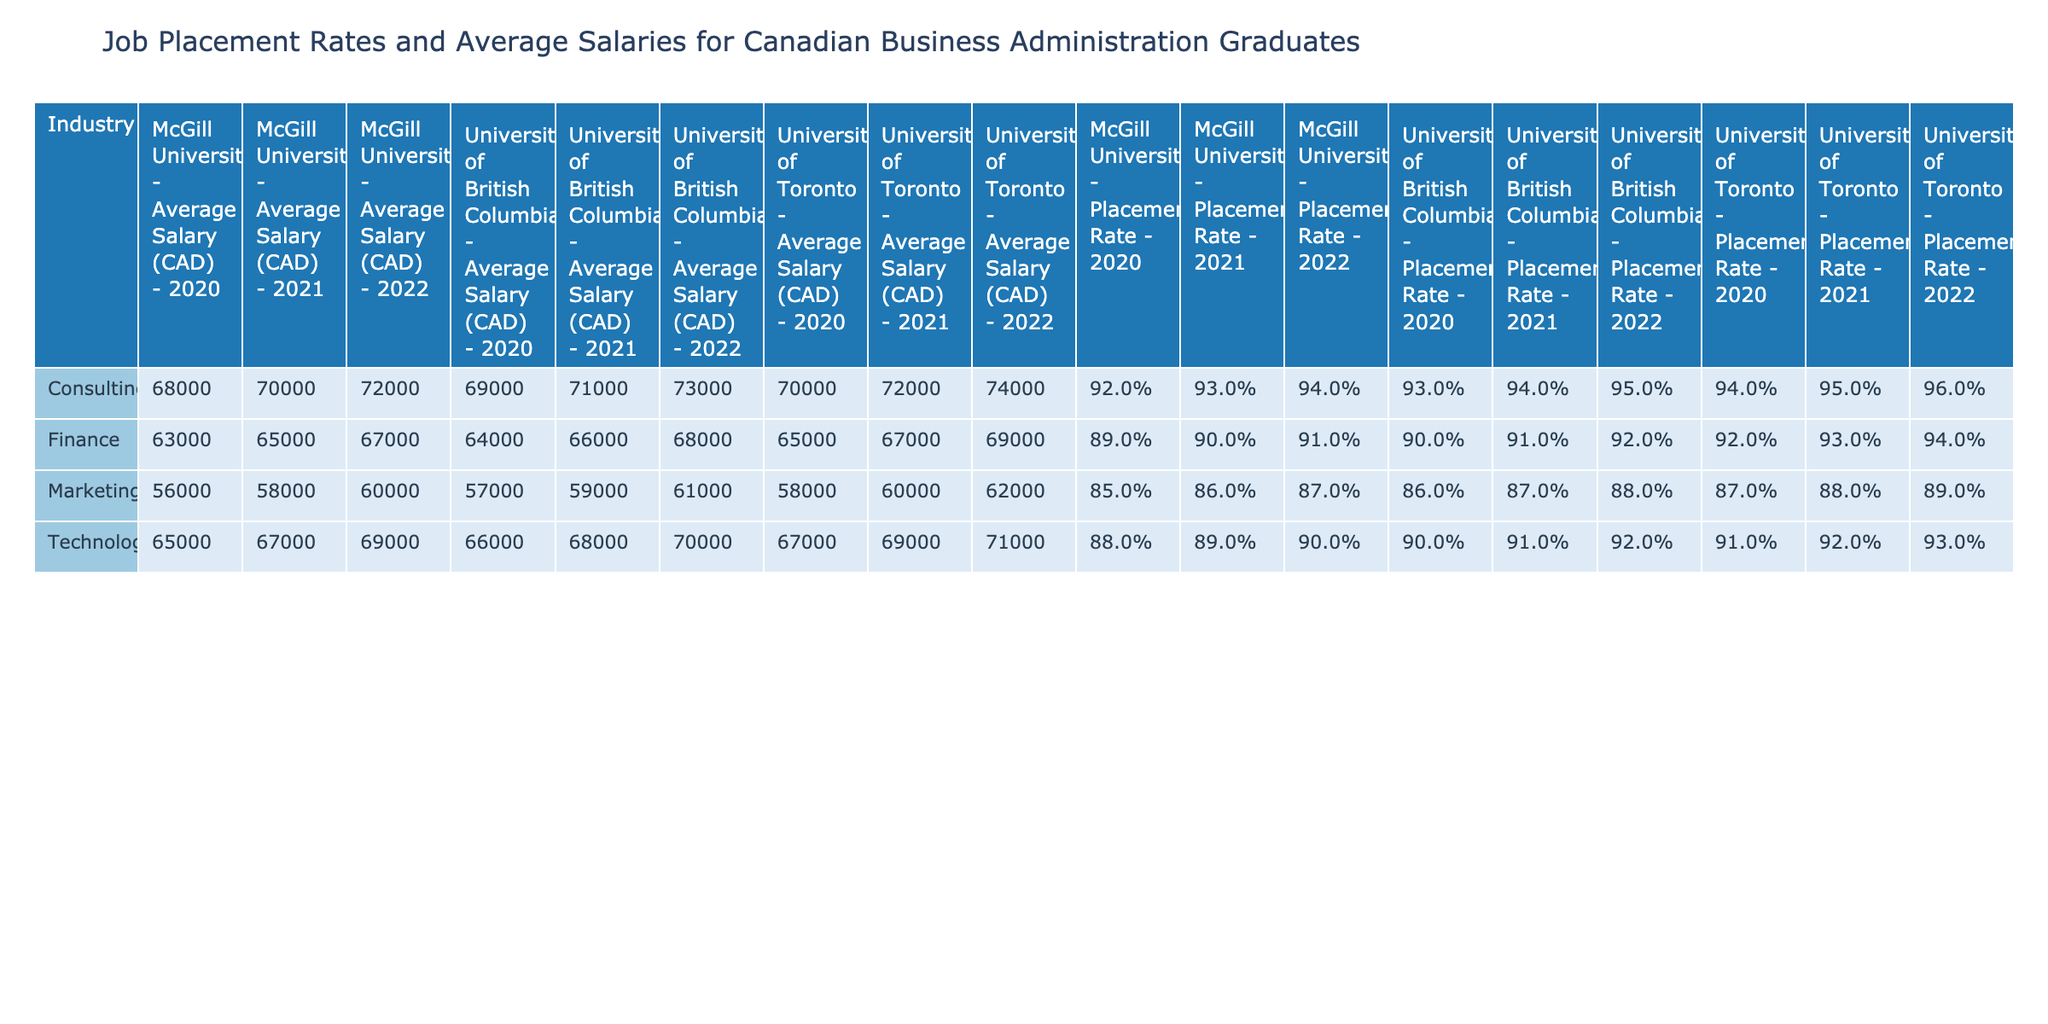What is the highest placement rate in the Consulting industry for 2021? The highest placement rate for Consulting in 2021 is from the University of Toronto with a rate of 95%.
Answer: 95% What is the average salary of Marketing graduates from University of British Columbia in 2020? The average salary of Marketing graduates from University of British Columbia in 2020 is 57,000 CAD.
Answer: 57,000 CAD Which university had the highest average salary for Finance graduates in 2022? The highest average salary for Finance graduates in 2022 was from the University of Toronto, which had an average salary of 69,000 CAD.
Answer: University of Toronto Is the placement rate for Technology graduates from McGill University higher than that of University of British Columbia in 2021? The placement rate for Technology graduates from McGill University in 2021 is 89%, while from University of British Columbia it is 91%. Since 89% is less than 91%, the statement is false.
Answer: No What is the difference between the average placement rates of Consulting graduates for 2020 and 2021 from University of British Columbia? The average placement rate for Consulting graduates from University of British Columbia in 2020 is 93% and in 2021 is 94%. The difference is calculated as 94% - 93% = 1%.
Answer: 1% What is the average placement rate for Marketing graduates across all universities in 2020? The placement rates for Marketing in 2020 are 87% (University of Toronto), 85% (McGill), and 86% (UBC). Summing these gives 258%, and dividing by 3 gives an average of 86%.
Answer: 86% Which industry had the lowest average placement rate for the year 2021? The lowest average placement rate in 2021 can be calculated by considering the rates for each industry. For Marketing, the average is 87.0%, while for Consulting it is 94.0% and for Technology it is 90.0%. Since Marketing is the lowest, the answer is Marketing.
Answer: Marketing Is it true that all industries had increased placement rates from 2020 to 2021? Comparing the rates, Consulting increased from 94% to 95% and Finance from 90% to 93%. However, Technology decreased from 91% to 89% in 2021, so it is not true that all industries had increased rates.
Answer: No What is the average salary for Consulting graduates from all universities in 2022? The average salaries in Consulting for 2022 are 74,000 CAD (University of Toronto), 72,000 CAD (McGill), and 73,000 CAD (UBC). Adding these gives 219,000 CAD, and dividing by 3 gives an average of 73,000 CAD.
Answer: 73,000 CAD 